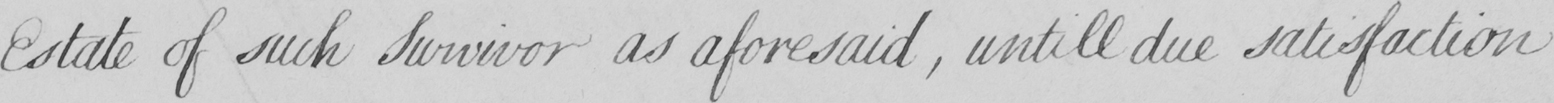What is written in this line of handwriting? Estate of such Survivor as aforesaid , untill due satisfaction 